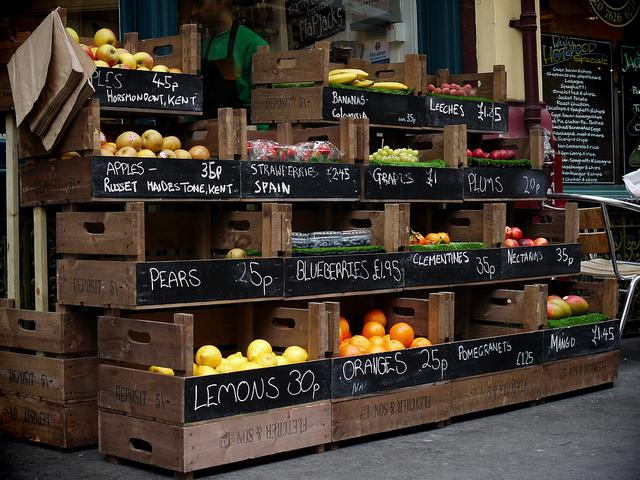What language must someone speak in order to understand what items are offered? Please explain your reasoning. english. Everything is written down in english. 